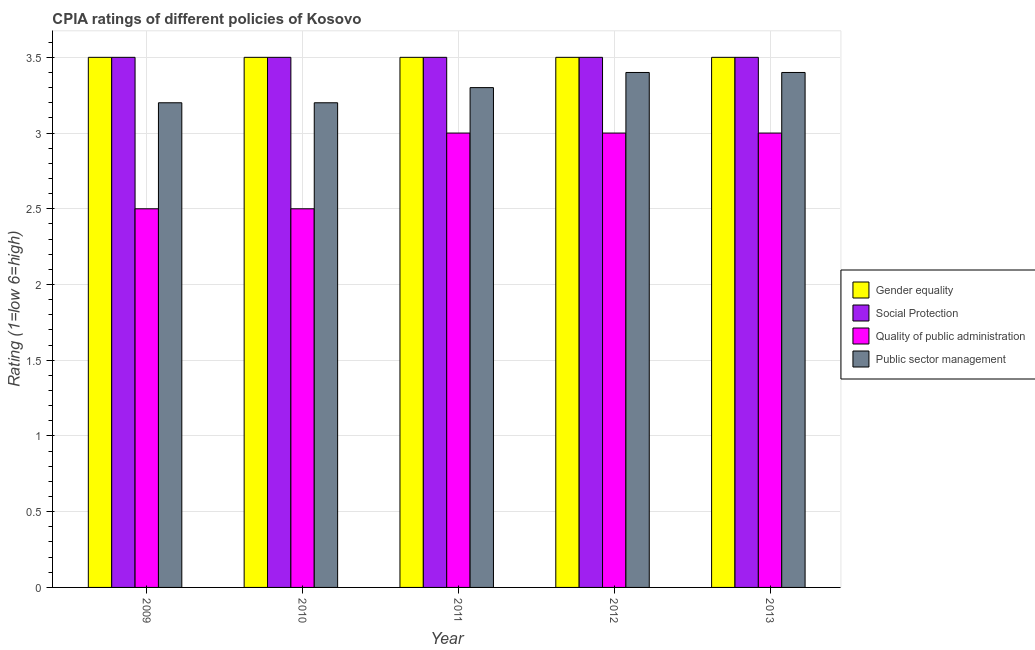How many groups of bars are there?
Ensure brevity in your answer.  5. Are the number of bars per tick equal to the number of legend labels?
Provide a succinct answer. Yes. Are the number of bars on each tick of the X-axis equal?
Your answer should be compact. Yes. What is the label of the 3rd group of bars from the left?
Give a very brief answer. 2011. In how many cases, is the number of bars for a given year not equal to the number of legend labels?
Make the answer very short. 0. What is the cpia rating of social protection in 2013?
Your answer should be very brief. 3.5. In which year was the cpia rating of quality of public administration maximum?
Keep it short and to the point. 2011. In which year was the cpia rating of public sector management minimum?
Ensure brevity in your answer.  2009. What is the total cpia rating of social protection in the graph?
Ensure brevity in your answer.  17.5. What is the difference between the cpia rating of public sector management in 2013 and the cpia rating of social protection in 2012?
Ensure brevity in your answer.  0. In the year 2012, what is the difference between the cpia rating of public sector management and cpia rating of gender equality?
Provide a succinct answer. 0. What is the ratio of the cpia rating of quality of public administration in 2010 to that in 2011?
Make the answer very short. 0.83. What is the difference between the highest and the lowest cpia rating of quality of public administration?
Your answer should be compact. 0.5. In how many years, is the cpia rating of quality of public administration greater than the average cpia rating of quality of public administration taken over all years?
Provide a short and direct response. 3. What does the 3rd bar from the left in 2012 represents?
Provide a short and direct response. Quality of public administration. What does the 1st bar from the right in 2009 represents?
Your response must be concise. Public sector management. Is it the case that in every year, the sum of the cpia rating of gender equality and cpia rating of social protection is greater than the cpia rating of quality of public administration?
Make the answer very short. Yes. How many bars are there?
Give a very brief answer. 20. What is the difference between two consecutive major ticks on the Y-axis?
Keep it short and to the point. 0.5. Does the graph contain grids?
Make the answer very short. Yes. How many legend labels are there?
Provide a short and direct response. 4. How are the legend labels stacked?
Your answer should be very brief. Vertical. What is the title of the graph?
Provide a short and direct response. CPIA ratings of different policies of Kosovo. What is the label or title of the X-axis?
Your answer should be very brief. Year. What is the Rating (1=low 6=high) in Public sector management in 2009?
Make the answer very short. 3.2. What is the Rating (1=low 6=high) of Gender equality in 2010?
Provide a short and direct response. 3.5. What is the Rating (1=low 6=high) in Public sector management in 2010?
Keep it short and to the point. 3.2. What is the Rating (1=low 6=high) in Gender equality in 2011?
Provide a short and direct response. 3.5. What is the Rating (1=low 6=high) of Gender equality in 2012?
Give a very brief answer. 3.5. What is the Rating (1=low 6=high) in Social Protection in 2012?
Make the answer very short. 3.5. What is the Rating (1=low 6=high) in Quality of public administration in 2012?
Your answer should be compact. 3. What is the Rating (1=low 6=high) in Public sector management in 2012?
Offer a terse response. 3.4. What is the Rating (1=low 6=high) of Social Protection in 2013?
Give a very brief answer. 3.5. Across all years, what is the maximum Rating (1=low 6=high) of Social Protection?
Make the answer very short. 3.5. Across all years, what is the minimum Rating (1=low 6=high) in Gender equality?
Your response must be concise. 3.5. Across all years, what is the minimum Rating (1=low 6=high) in Quality of public administration?
Provide a succinct answer. 2.5. Across all years, what is the minimum Rating (1=low 6=high) of Public sector management?
Make the answer very short. 3.2. What is the total Rating (1=low 6=high) in Social Protection in the graph?
Make the answer very short. 17.5. What is the total Rating (1=low 6=high) of Quality of public administration in the graph?
Your answer should be compact. 14. What is the difference between the Rating (1=low 6=high) of Gender equality in 2009 and that in 2010?
Your response must be concise. 0. What is the difference between the Rating (1=low 6=high) of Public sector management in 2009 and that in 2010?
Your answer should be very brief. 0. What is the difference between the Rating (1=low 6=high) in Social Protection in 2009 and that in 2011?
Keep it short and to the point. 0. What is the difference between the Rating (1=low 6=high) in Quality of public administration in 2009 and that in 2011?
Your answer should be very brief. -0.5. What is the difference between the Rating (1=low 6=high) in Social Protection in 2009 and that in 2012?
Provide a succinct answer. 0. What is the difference between the Rating (1=low 6=high) of Public sector management in 2009 and that in 2012?
Provide a short and direct response. -0.2. What is the difference between the Rating (1=low 6=high) in Public sector management in 2010 and that in 2011?
Make the answer very short. -0.1. What is the difference between the Rating (1=low 6=high) of Social Protection in 2010 and that in 2012?
Offer a very short reply. 0. What is the difference between the Rating (1=low 6=high) in Social Protection in 2011 and that in 2012?
Your answer should be compact. 0. What is the difference between the Rating (1=low 6=high) of Quality of public administration in 2011 and that in 2012?
Make the answer very short. 0. What is the difference between the Rating (1=low 6=high) in Social Protection in 2011 and that in 2013?
Make the answer very short. 0. What is the difference between the Rating (1=low 6=high) in Social Protection in 2012 and that in 2013?
Your answer should be very brief. 0. What is the difference between the Rating (1=low 6=high) in Public sector management in 2012 and that in 2013?
Keep it short and to the point. 0. What is the difference between the Rating (1=low 6=high) of Gender equality in 2009 and the Rating (1=low 6=high) of Quality of public administration in 2010?
Give a very brief answer. 1. What is the difference between the Rating (1=low 6=high) of Gender equality in 2009 and the Rating (1=low 6=high) of Public sector management in 2010?
Ensure brevity in your answer.  0.3. What is the difference between the Rating (1=low 6=high) of Social Protection in 2009 and the Rating (1=low 6=high) of Quality of public administration in 2010?
Give a very brief answer. 1. What is the difference between the Rating (1=low 6=high) in Gender equality in 2009 and the Rating (1=low 6=high) in Quality of public administration in 2011?
Give a very brief answer. 0.5. What is the difference between the Rating (1=low 6=high) of Gender equality in 2009 and the Rating (1=low 6=high) of Public sector management in 2011?
Offer a terse response. 0.2. What is the difference between the Rating (1=low 6=high) of Social Protection in 2009 and the Rating (1=low 6=high) of Quality of public administration in 2011?
Provide a succinct answer. 0.5. What is the difference between the Rating (1=low 6=high) of Quality of public administration in 2009 and the Rating (1=low 6=high) of Public sector management in 2011?
Offer a terse response. -0.8. What is the difference between the Rating (1=low 6=high) in Gender equality in 2009 and the Rating (1=low 6=high) in Social Protection in 2012?
Your response must be concise. 0. What is the difference between the Rating (1=low 6=high) in Gender equality in 2009 and the Rating (1=low 6=high) in Quality of public administration in 2012?
Offer a very short reply. 0.5. What is the difference between the Rating (1=low 6=high) of Gender equality in 2009 and the Rating (1=low 6=high) of Public sector management in 2012?
Your answer should be compact. 0.1. What is the difference between the Rating (1=low 6=high) of Social Protection in 2009 and the Rating (1=low 6=high) of Quality of public administration in 2012?
Make the answer very short. 0.5. What is the difference between the Rating (1=low 6=high) of Social Protection in 2009 and the Rating (1=low 6=high) of Public sector management in 2012?
Offer a terse response. 0.1. What is the difference between the Rating (1=low 6=high) in Quality of public administration in 2009 and the Rating (1=low 6=high) in Public sector management in 2012?
Make the answer very short. -0.9. What is the difference between the Rating (1=low 6=high) in Gender equality in 2009 and the Rating (1=low 6=high) in Public sector management in 2013?
Offer a very short reply. 0.1. What is the difference between the Rating (1=low 6=high) of Social Protection in 2009 and the Rating (1=low 6=high) of Quality of public administration in 2013?
Your response must be concise. 0.5. What is the difference between the Rating (1=low 6=high) in Social Protection in 2009 and the Rating (1=low 6=high) in Public sector management in 2013?
Keep it short and to the point. 0.1. What is the difference between the Rating (1=low 6=high) of Quality of public administration in 2009 and the Rating (1=low 6=high) of Public sector management in 2013?
Your answer should be very brief. -0.9. What is the difference between the Rating (1=low 6=high) of Social Protection in 2010 and the Rating (1=low 6=high) of Quality of public administration in 2011?
Ensure brevity in your answer.  0.5. What is the difference between the Rating (1=low 6=high) of Social Protection in 2010 and the Rating (1=low 6=high) of Public sector management in 2011?
Your response must be concise. 0.2. What is the difference between the Rating (1=low 6=high) of Gender equality in 2010 and the Rating (1=low 6=high) of Social Protection in 2012?
Provide a succinct answer. 0. What is the difference between the Rating (1=low 6=high) of Social Protection in 2010 and the Rating (1=low 6=high) of Quality of public administration in 2012?
Give a very brief answer. 0.5. What is the difference between the Rating (1=low 6=high) in Social Protection in 2010 and the Rating (1=low 6=high) in Public sector management in 2012?
Your response must be concise. 0.1. What is the difference between the Rating (1=low 6=high) of Quality of public administration in 2010 and the Rating (1=low 6=high) of Public sector management in 2012?
Your response must be concise. -0.9. What is the difference between the Rating (1=low 6=high) of Gender equality in 2010 and the Rating (1=low 6=high) of Social Protection in 2013?
Ensure brevity in your answer.  0. What is the difference between the Rating (1=low 6=high) in Gender equality in 2010 and the Rating (1=low 6=high) in Quality of public administration in 2013?
Your response must be concise. 0.5. What is the difference between the Rating (1=low 6=high) of Gender equality in 2010 and the Rating (1=low 6=high) of Public sector management in 2013?
Offer a very short reply. 0.1. What is the difference between the Rating (1=low 6=high) of Social Protection in 2010 and the Rating (1=low 6=high) of Quality of public administration in 2013?
Ensure brevity in your answer.  0.5. What is the difference between the Rating (1=low 6=high) of Social Protection in 2010 and the Rating (1=low 6=high) of Public sector management in 2013?
Provide a short and direct response. 0.1. What is the difference between the Rating (1=low 6=high) in Quality of public administration in 2010 and the Rating (1=low 6=high) in Public sector management in 2013?
Your response must be concise. -0.9. What is the difference between the Rating (1=low 6=high) of Gender equality in 2011 and the Rating (1=low 6=high) of Social Protection in 2012?
Offer a terse response. 0. What is the difference between the Rating (1=low 6=high) of Gender equality in 2011 and the Rating (1=low 6=high) of Quality of public administration in 2012?
Offer a terse response. 0.5. What is the difference between the Rating (1=low 6=high) in Gender equality in 2011 and the Rating (1=low 6=high) in Public sector management in 2012?
Offer a terse response. 0.1. What is the difference between the Rating (1=low 6=high) in Social Protection in 2011 and the Rating (1=low 6=high) in Quality of public administration in 2012?
Provide a succinct answer. 0.5. What is the difference between the Rating (1=low 6=high) of Gender equality in 2011 and the Rating (1=low 6=high) of Social Protection in 2013?
Ensure brevity in your answer.  0. What is the difference between the Rating (1=low 6=high) in Gender equality in 2011 and the Rating (1=low 6=high) in Public sector management in 2013?
Your answer should be compact. 0.1. What is the difference between the Rating (1=low 6=high) in Social Protection in 2011 and the Rating (1=low 6=high) in Quality of public administration in 2013?
Keep it short and to the point. 0.5. What is the difference between the Rating (1=low 6=high) of Quality of public administration in 2011 and the Rating (1=low 6=high) of Public sector management in 2013?
Keep it short and to the point. -0.4. What is the difference between the Rating (1=low 6=high) in Gender equality in 2012 and the Rating (1=low 6=high) in Social Protection in 2013?
Keep it short and to the point. 0. What is the difference between the Rating (1=low 6=high) in Gender equality in 2012 and the Rating (1=low 6=high) in Public sector management in 2013?
Keep it short and to the point. 0.1. What is the difference between the Rating (1=low 6=high) in Social Protection in 2012 and the Rating (1=low 6=high) in Quality of public administration in 2013?
Provide a short and direct response. 0.5. What is the difference between the Rating (1=low 6=high) of Social Protection in 2012 and the Rating (1=low 6=high) of Public sector management in 2013?
Your answer should be very brief. 0.1. What is the average Rating (1=low 6=high) in Gender equality per year?
Offer a very short reply. 3.5. What is the average Rating (1=low 6=high) of Social Protection per year?
Provide a succinct answer. 3.5. What is the average Rating (1=low 6=high) in Quality of public administration per year?
Keep it short and to the point. 2.8. What is the average Rating (1=low 6=high) in Public sector management per year?
Keep it short and to the point. 3.3. In the year 2009, what is the difference between the Rating (1=low 6=high) in Gender equality and Rating (1=low 6=high) in Quality of public administration?
Give a very brief answer. 1. In the year 2009, what is the difference between the Rating (1=low 6=high) of Social Protection and Rating (1=low 6=high) of Quality of public administration?
Keep it short and to the point. 1. In the year 2009, what is the difference between the Rating (1=low 6=high) of Quality of public administration and Rating (1=low 6=high) of Public sector management?
Your answer should be compact. -0.7. In the year 2010, what is the difference between the Rating (1=low 6=high) of Gender equality and Rating (1=low 6=high) of Public sector management?
Ensure brevity in your answer.  0.3. In the year 2010, what is the difference between the Rating (1=low 6=high) of Social Protection and Rating (1=low 6=high) of Quality of public administration?
Your answer should be very brief. 1. In the year 2010, what is the difference between the Rating (1=low 6=high) in Social Protection and Rating (1=low 6=high) in Public sector management?
Ensure brevity in your answer.  0.3. In the year 2011, what is the difference between the Rating (1=low 6=high) in Gender equality and Rating (1=low 6=high) in Public sector management?
Keep it short and to the point. 0.2. In the year 2012, what is the difference between the Rating (1=low 6=high) of Gender equality and Rating (1=low 6=high) of Public sector management?
Give a very brief answer. 0.1. In the year 2012, what is the difference between the Rating (1=low 6=high) in Quality of public administration and Rating (1=low 6=high) in Public sector management?
Your response must be concise. -0.4. In the year 2013, what is the difference between the Rating (1=low 6=high) of Gender equality and Rating (1=low 6=high) of Public sector management?
Ensure brevity in your answer.  0.1. In the year 2013, what is the difference between the Rating (1=low 6=high) of Social Protection and Rating (1=low 6=high) of Public sector management?
Provide a succinct answer. 0.1. What is the ratio of the Rating (1=low 6=high) in Gender equality in 2009 to that in 2010?
Offer a terse response. 1. What is the ratio of the Rating (1=low 6=high) in Social Protection in 2009 to that in 2010?
Provide a succinct answer. 1. What is the ratio of the Rating (1=low 6=high) in Quality of public administration in 2009 to that in 2010?
Make the answer very short. 1. What is the ratio of the Rating (1=low 6=high) in Public sector management in 2009 to that in 2010?
Your answer should be very brief. 1. What is the ratio of the Rating (1=low 6=high) in Gender equality in 2009 to that in 2011?
Ensure brevity in your answer.  1. What is the ratio of the Rating (1=low 6=high) of Quality of public administration in 2009 to that in 2011?
Keep it short and to the point. 0.83. What is the ratio of the Rating (1=low 6=high) in Public sector management in 2009 to that in 2011?
Ensure brevity in your answer.  0.97. What is the ratio of the Rating (1=low 6=high) in Social Protection in 2009 to that in 2012?
Your answer should be very brief. 1. What is the ratio of the Rating (1=low 6=high) of Quality of public administration in 2009 to that in 2012?
Offer a terse response. 0.83. What is the ratio of the Rating (1=low 6=high) of Public sector management in 2009 to that in 2012?
Your response must be concise. 0.94. What is the ratio of the Rating (1=low 6=high) of Gender equality in 2009 to that in 2013?
Ensure brevity in your answer.  1. What is the ratio of the Rating (1=low 6=high) in Quality of public administration in 2009 to that in 2013?
Make the answer very short. 0.83. What is the ratio of the Rating (1=low 6=high) in Public sector management in 2009 to that in 2013?
Ensure brevity in your answer.  0.94. What is the ratio of the Rating (1=low 6=high) in Public sector management in 2010 to that in 2011?
Provide a succinct answer. 0.97. What is the ratio of the Rating (1=low 6=high) in Gender equality in 2010 to that in 2012?
Give a very brief answer. 1. What is the ratio of the Rating (1=low 6=high) in Gender equality in 2010 to that in 2013?
Provide a short and direct response. 1. What is the ratio of the Rating (1=low 6=high) of Quality of public administration in 2010 to that in 2013?
Make the answer very short. 0.83. What is the ratio of the Rating (1=low 6=high) of Public sector management in 2010 to that in 2013?
Offer a very short reply. 0.94. What is the ratio of the Rating (1=low 6=high) in Social Protection in 2011 to that in 2012?
Make the answer very short. 1. What is the ratio of the Rating (1=low 6=high) of Quality of public administration in 2011 to that in 2012?
Keep it short and to the point. 1. What is the ratio of the Rating (1=low 6=high) in Public sector management in 2011 to that in 2012?
Your answer should be compact. 0.97. What is the ratio of the Rating (1=low 6=high) in Public sector management in 2011 to that in 2013?
Make the answer very short. 0.97. What is the ratio of the Rating (1=low 6=high) in Social Protection in 2012 to that in 2013?
Keep it short and to the point. 1. What is the ratio of the Rating (1=low 6=high) in Quality of public administration in 2012 to that in 2013?
Provide a short and direct response. 1. What is the difference between the highest and the second highest Rating (1=low 6=high) of Gender equality?
Offer a terse response. 0. What is the difference between the highest and the second highest Rating (1=low 6=high) of Social Protection?
Ensure brevity in your answer.  0. What is the difference between the highest and the second highest Rating (1=low 6=high) in Public sector management?
Your response must be concise. 0. What is the difference between the highest and the lowest Rating (1=low 6=high) in Gender equality?
Keep it short and to the point. 0. What is the difference between the highest and the lowest Rating (1=low 6=high) in Public sector management?
Your answer should be very brief. 0.2. 